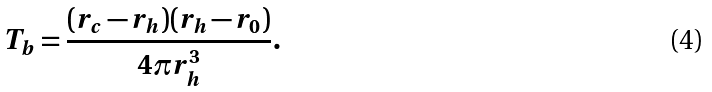<formula> <loc_0><loc_0><loc_500><loc_500>T _ { b } = \frac { ( r _ { c } - r _ { h } ) ( r _ { h } - r _ { 0 } ) } { 4 \pi r _ { h } ^ { 3 } } .</formula> 